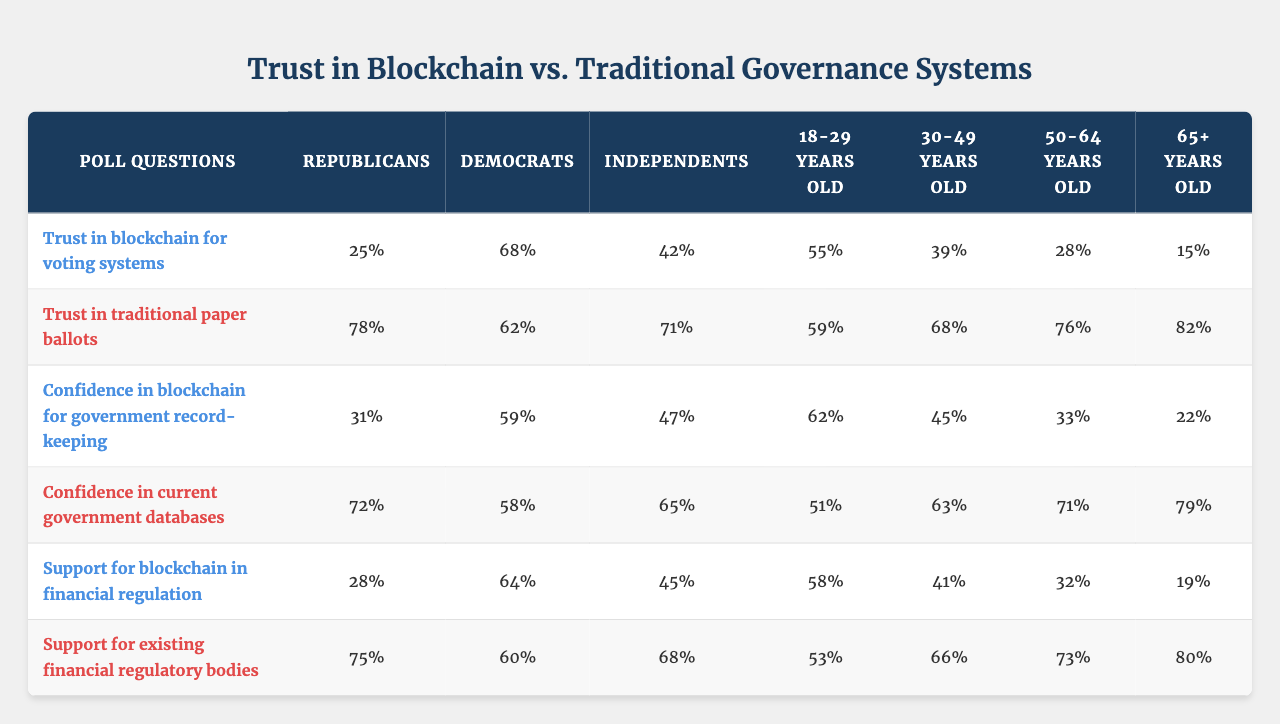What is the trust score in blockchain for voting systems among Republicans? According to the table, the trust score for blockchain in voting systems among Republicans is clearly mentioned in the corresponding row and column, which shows a score of 25%.
Answer: 25% What is the trust score for traditional paper ballots among Independents? The data shows that the trust score for traditional paper ballots among Independents is 71%. This can be found in the row for traditional paper ballots and the column for Independents.
Answer: 71% How does the trust in blockchain for voting systems compare to the trust in traditional paper ballots among Democrats? From the table, Democrats have a trust score of 68% in blockchain voting systems and 62% in traditional paper ballots. The difference is calculated as 68% - 62% = 6%.
Answer: 6% Which demographic group has the highest trust score for current government databases? Inspecting the table, the 65+ demographic has the highest score of 79% for current government databases, as shown in the relevant row and column, which indicates that this group trusts traditional methods the most.
Answer: 79% What is the average trust score in blockchain for government record-keeping across all demographic groups? To find the average, we sum up the trust scores for blockchain in government record-keeping: (31 + 59 + 47 + 62 + 45 + 33 + 22) = 299. There are 7 groups, so the average is 299 / 7 = 42.71%.
Answer: 42.71% Is the trust score in blockchain for financial regulation higher or lower than the trust score in existing financial regulatory bodies among 30-49 year-olds? The trust score in blockchain for financial regulation is 58% and for existing financial regulatory bodies is 53% among the 30-49 year-olds. Since 58% is greater than 53%, blockchain has higher trust.
Answer: Higher What demographic group shows the least trust in blockchain for voting systems? By analyzing the table, 65+ years old shows the least trust in blockchain for voting systems with a score of 15%, which is the lowest among all demographic groups listed.
Answer: 15% What is the difference in support for blockchain in financial regulation between Democrats and 18-29 year-olds? The support for blockchain in financial regulation among Democrats is 64%, while for 18-29 year-olds it is 58%. The difference is calculated as 64% - 58% = 6%.
Answer: 6% Is there a trend in trust scores for blockchain related to age demographics? By examining the trust scores for blockchain across age demographics, we see a decline in scores from younger to older age groups, suggesting that trust diminishes with age.
Answer: Yes What is the maximum trust score for traditional governance systems among all demographic groups? The maximum trust score for traditional governance systems appears in the row for traditional paper ballots, specifically among Republicans, with a score of 78%, visible from the relevant section in the table.
Answer: 78% Which demographic has the lowest confidence in current government databases? Referencing the table, the 65+ demographic has the lowest confidence in current government databases, scoring 79%, the highest, thus all other groups have higher confidence.
Answer: 51% 